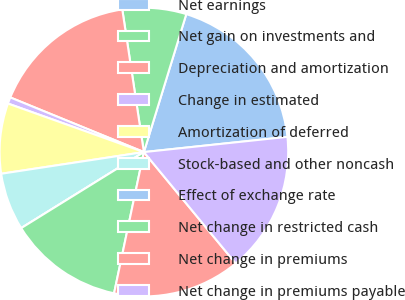Convert chart. <chart><loc_0><loc_0><loc_500><loc_500><pie_chart><fcel>Net earnings<fcel>Net gain on investments and<fcel>Depreciation and amortization<fcel>Change in estimated<fcel>Amortization of deferred<fcel>Stock-based and other noncash<fcel>Effect of exchange rate<fcel>Net change in restricted cash<fcel>Net change in premiums<fcel>Net change in premiums payable<nl><fcel>18.57%<fcel>7.14%<fcel>16.43%<fcel>0.72%<fcel>7.86%<fcel>6.43%<fcel>0.0%<fcel>12.86%<fcel>14.29%<fcel>15.71%<nl></chart> 